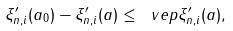<formula> <loc_0><loc_0><loc_500><loc_500>\| \xi _ { n , i } ^ { \prime } ( a _ { 0 } ) - \xi _ { n , i } ^ { \prime } ( a ) \| \leq \ v e p \| \xi _ { n , i } ^ { \prime } ( a ) \| ,</formula> 